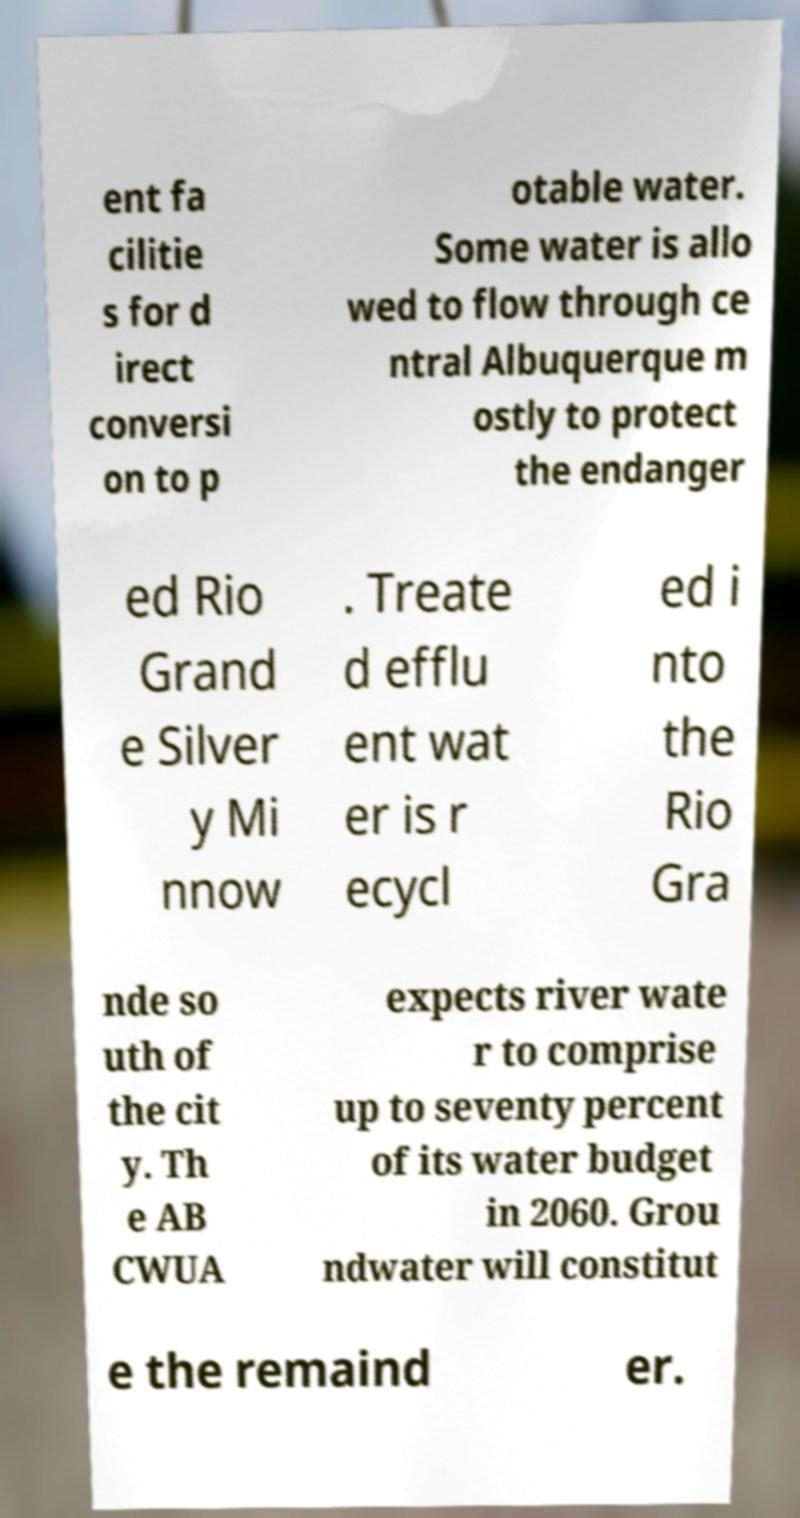Could you assist in decoding the text presented in this image and type it out clearly? ent fa cilitie s for d irect conversi on to p otable water. Some water is allo wed to flow through ce ntral Albuquerque m ostly to protect the endanger ed Rio Grand e Silver y Mi nnow . Treate d efflu ent wat er is r ecycl ed i nto the Rio Gra nde so uth of the cit y. Th e AB CWUA expects river wate r to comprise up to seventy percent of its water budget in 2060. Grou ndwater will constitut e the remaind er. 